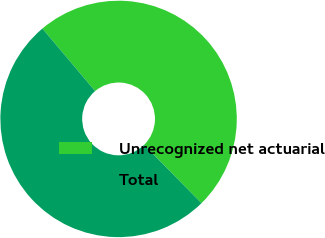<chart> <loc_0><loc_0><loc_500><loc_500><pie_chart><fcel>Unrecognized net actuarial<fcel>Total<nl><fcel>48.78%<fcel>51.22%<nl></chart> 